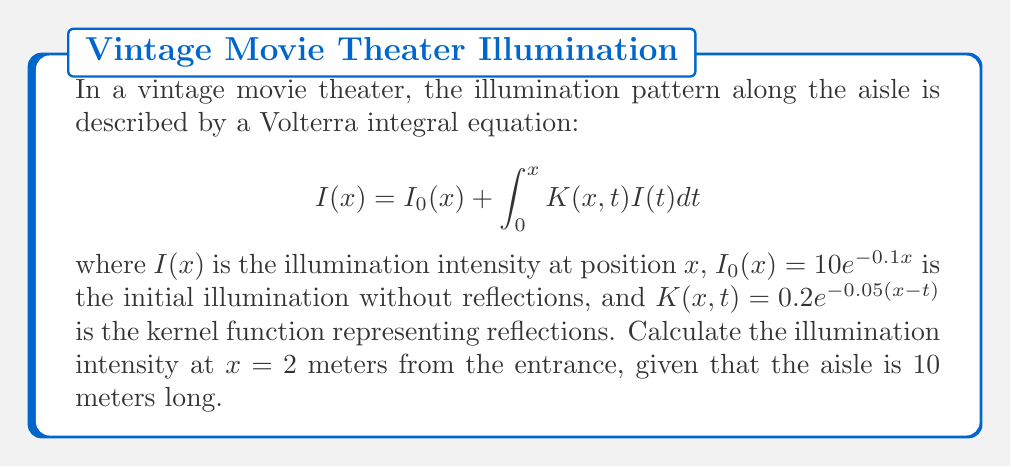Solve this math problem. To solve this Volterra integral equation, we'll use the method of successive approximations:

1) Start with the initial approximation $I_0(x) = 10e^{-0.1x}$

2) Calculate the next approximation:
   $$I_1(x) = I_0(x) + \int_0^x K(x,t)I_0(t)dt$$
   
   $$I_1(x) = 10e^{-0.1x} + \int_0^x 0.2e^{-0.05(x-t)}(10e^{-0.1t})dt$$

3) Evaluate the integral:
   $$I_1(x) = 10e^{-0.1x} + 2e^{-0.05x}\int_0^x e^{0.05t}e^{-0.1t}dt$$
   $$= 10e^{-0.1x} + 2e^{-0.05x}\int_0^x e^{-0.05t}dt$$
   $$= 10e^{-0.1x} + 2e^{-0.05x}[-20e^{-0.05t}]_0^x$$
   $$= 10e^{-0.1x} + 2e^{-0.05x}(-20e^{-0.05x} + 20)$$
   $$= 10e^{-0.1x} + 40 - 40e^{-0.05x}$$

4) For $x = 2$:
   $$I_1(2) = 10e^{-0.2} + 40 - 40e^{-0.1}$$
   $$= 10(0.8187) + 40 - 40(0.9048)$$
   $$= 8.187 + 40 - 36.192 = 11.995$$

5) This approximation is usually sufficient for practical purposes, but for higher accuracy, we could continue the process to find $I_2(x)$, $I_3(x)$, etc.
Answer: 11.995 lux 